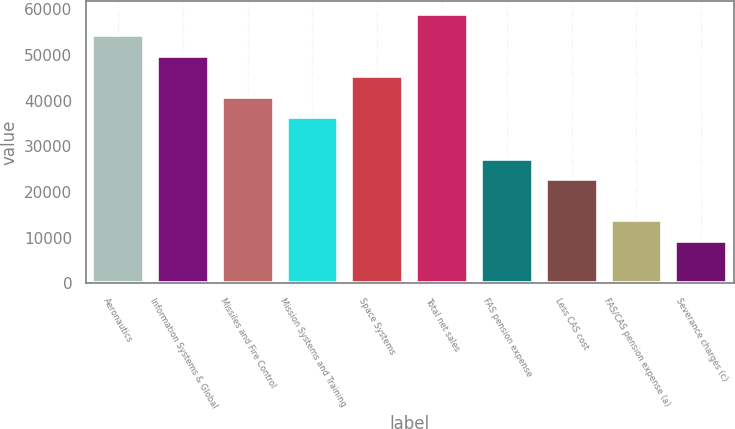Convert chart. <chart><loc_0><loc_0><loc_500><loc_500><bar_chart><fcel>Aeronautics<fcel>Information Systems & Global<fcel>Missiles and Fire Control<fcel>Mission Systems and Training<fcel>Space Systems<fcel>Total net sales<fcel>FAS pension expense<fcel>Less CAS cost<fcel>FAS/CAS pension expense (a)<fcel>Severance charges (c)<nl><fcel>54393.6<fcel>49875.8<fcel>40840.2<fcel>36322.4<fcel>45358<fcel>58911.4<fcel>27286.8<fcel>22769<fcel>13733.4<fcel>9215.6<nl></chart> 